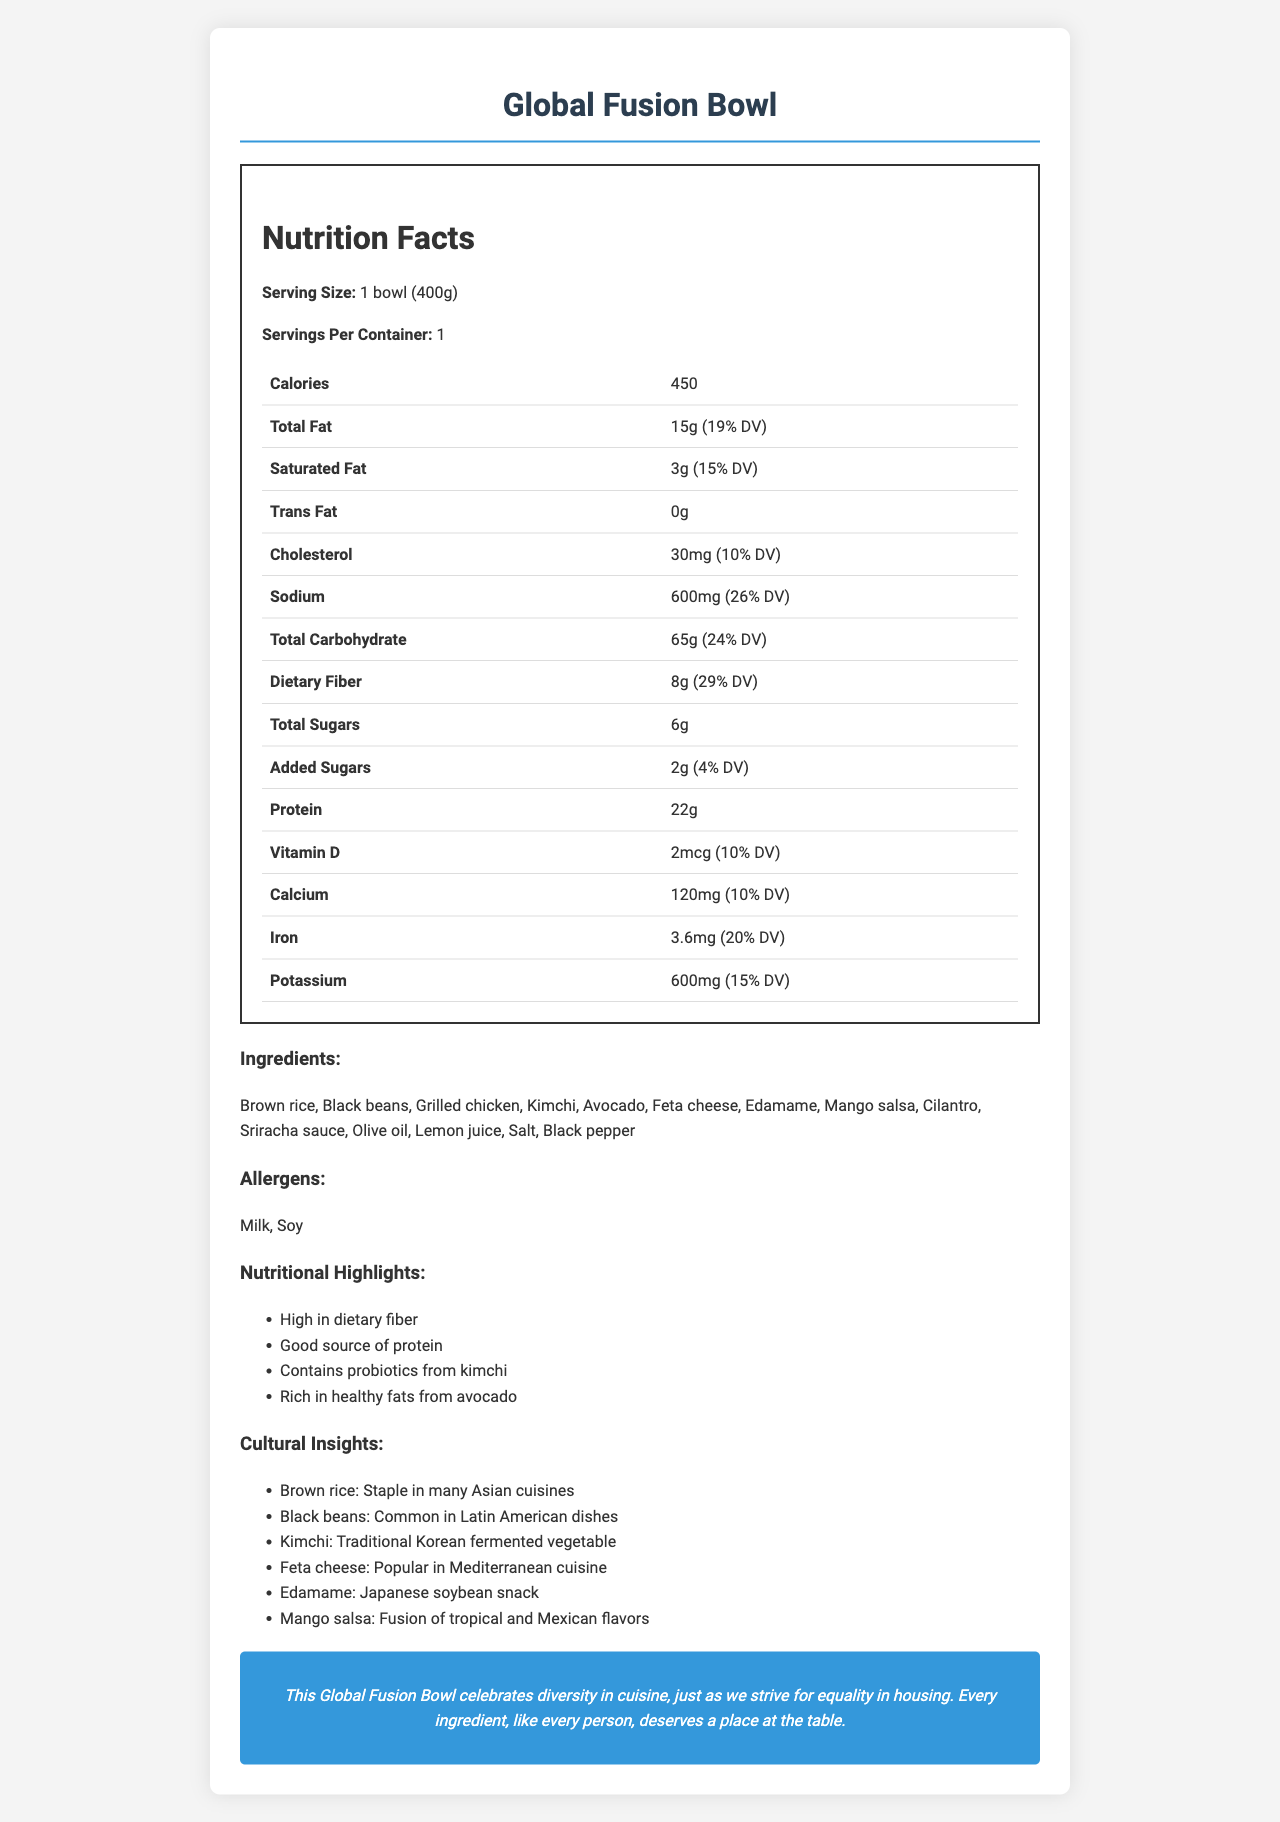short-answer: How many servings are in one container? The document states "Servings Per Container: 1".
Answer: 1 short-answer: What is the total fat content in grams per serving? The document lists "Total Fat: 15g".
Answer: 15g short-answer: How much sodium does the Global Fusion Bowl contain? The document states that the sodium content is "600mg".
Answer: 600mg short-answer: Which ingredient in the Global Fusion Bowl is a traditional Korean fermented vegetable? The cultural insights mention "Kimchi: Traditional Korean fermented vegetable".
Answer: Kimchi short-answer: What percentage of the daily value of dietary fiber does the Global Fusion Bowl provide? The document lists the dietary fiber as "8g (29% DV)".
Answer: 29% multiple-choice: How many grams of protein are in one serving of the Global Fusion Bowl? A. 15g B. 20g C. 22g D. 25g The document lists protein content as "22g".
Answer: C multiple-choice: Which cuisine does brown rice primarily belong to? I. Mediterranean II. Asian III. South American IV. European The cultural insights state "Brown rice: Staple in many Asian cuisines".
Answer: II yes/no: Does this meal contain any trans fat? The document shows "Trans Fat: 0g".
Answer: No summary: Summarize the key nutritional and cultural aspects of the Global Fusion Bowl. The Global Fusion Bowl is highlighted for its diverse ingredients and nutritional benefits. It incorporates elements from different cultures and emphasizes high dietary fiber and healthy fats. The meal is positioned as a celebration of diversity, similar to the advocacy for equality and inclusion in housing.
Answer: The Global Fusion Bowl is a culturally diverse meal featuring ingredients from various ethnic cuisines. Nutritionally, it is high in dietary fiber, a good source of protein, contains probiotics from kimchi, and is rich in healthy fats from avocado. It includes staple ingredients such as brown rice, black beans, and kimchi, which are common in Asian, Latin American, and Korean cuisine respectively. Additionally, it contains milk and soy allergens. The document emphasizes equality and diversity in food, aligning it with broader social values of inclusion. unanswerable: What is the price of the Global Fusion Bowl? The document does not provide any details about the price of the Global Fusion Bowl.
Answer: Not enough information 